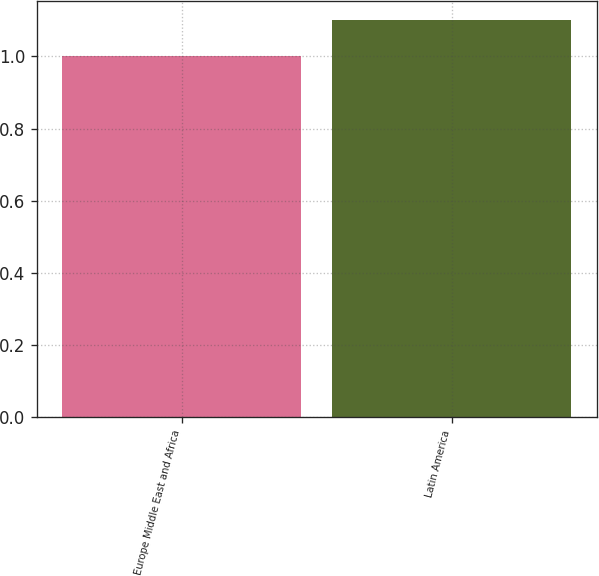Convert chart. <chart><loc_0><loc_0><loc_500><loc_500><bar_chart><fcel>Europe Middle East and Africa<fcel>Latin America<nl><fcel>1<fcel>1.1<nl></chart> 